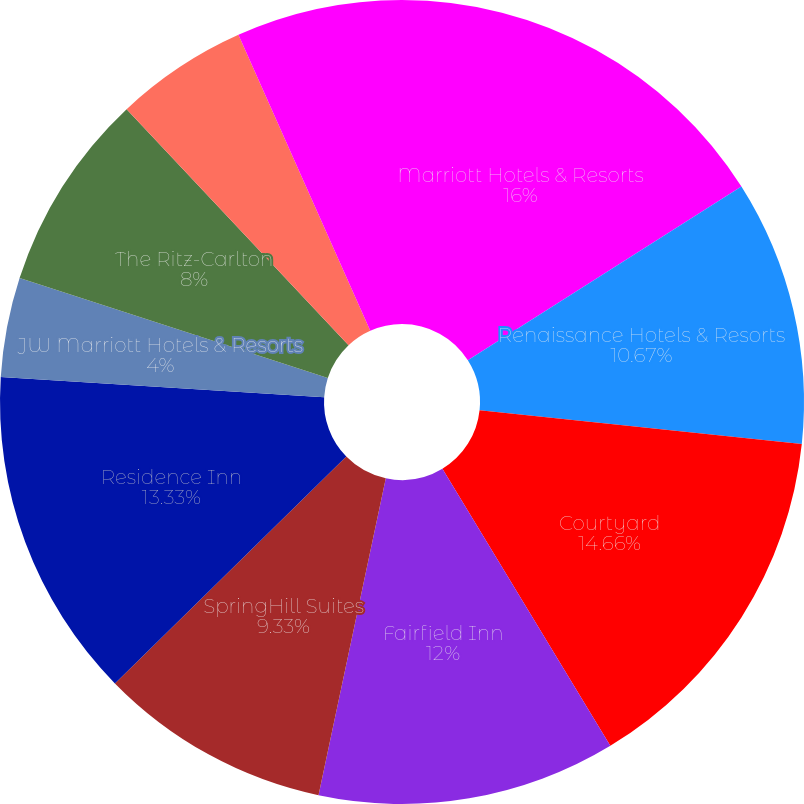Convert chart. <chart><loc_0><loc_0><loc_500><loc_500><pie_chart><fcel>Marriott Hotels & Resorts<fcel>Renaissance Hotels & Resorts<fcel>Courtyard<fcel>Fairfield Inn<fcel>SpringHill Suites<fcel>Residence Inn<fcel>JW Marriott Hotels & Resorts<fcel>The Ritz-Carlton<fcel>The Ritz-Carlton-Residential<fcel>Marriott Vacation Club<nl><fcel>16.0%<fcel>10.67%<fcel>14.66%<fcel>12.0%<fcel>9.33%<fcel>13.33%<fcel>4.0%<fcel>8.0%<fcel>5.34%<fcel>6.67%<nl></chart> 